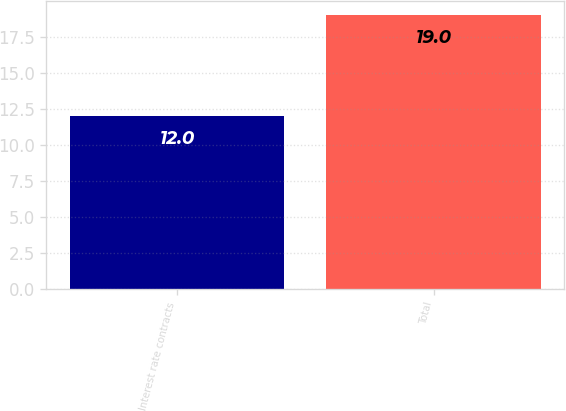<chart> <loc_0><loc_0><loc_500><loc_500><bar_chart><fcel>Interest rate contracts<fcel>Total<nl><fcel>12<fcel>19<nl></chart> 